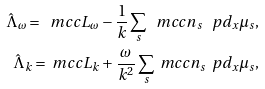<formula> <loc_0><loc_0><loc_500><loc_500>\hat { \Lambda } _ { \omega } = \ m c c { L } _ { \omega } - \frac { 1 } { k } \sum _ { s } \ m c c { n } _ { s } \, \ p d _ { x } \mu _ { s } , \\ \hat { \Lambda } _ { k } = \ m c c { L } _ { k } + \frac { \omega } { k ^ { 2 } } \sum _ { s } \ m c c { n } _ { s } \, \ p d _ { x } \mu _ { s } ,</formula> 